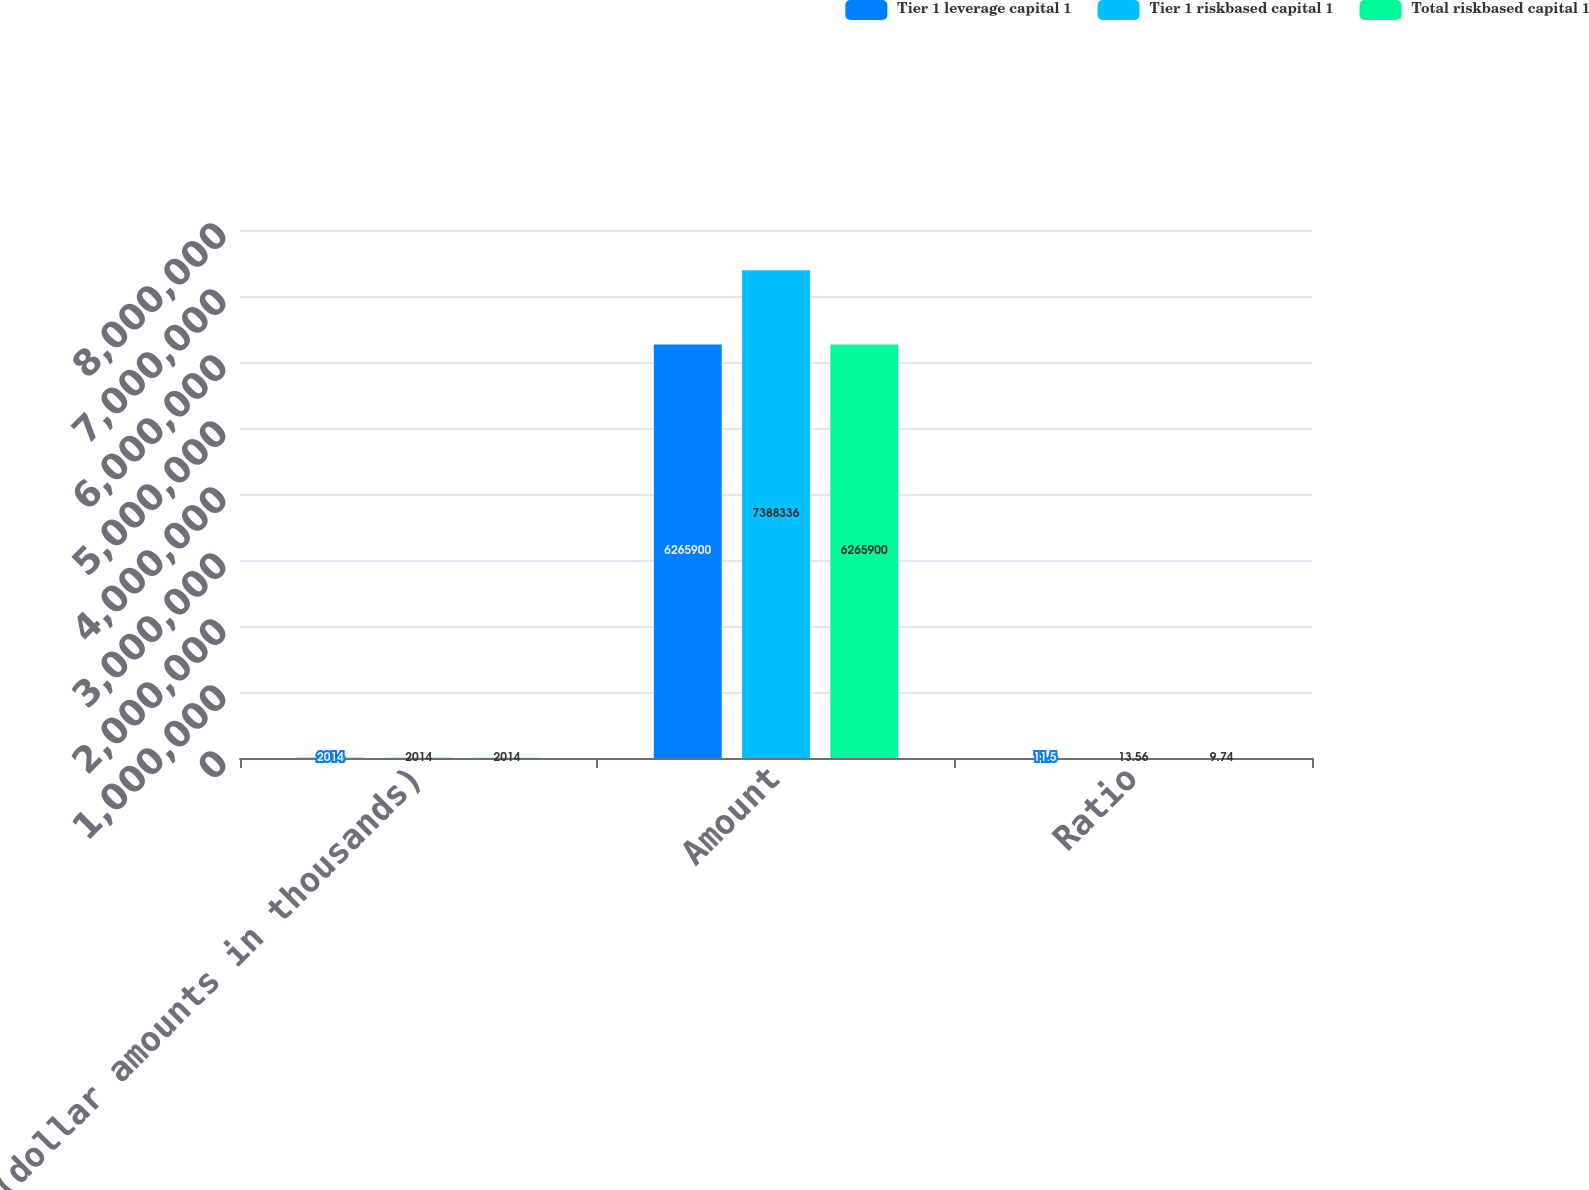<chart> <loc_0><loc_0><loc_500><loc_500><stacked_bar_chart><ecel><fcel>(dollar amounts in thousands)<fcel>Amount<fcel>Ratio<nl><fcel>Tier 1 leverage capital 1<fcel>2014<fcel>6.2659e+06<fcel>11.5<nl><fcel>Tier 1 riskbased capital 1<fcel>2014<fcel>7.38834e+06<fcel>13.56<nl><fcel>Total riskbased capital 1<fcel>2014<fcel>6.2659e+06<fcel>9.74<nl></chart> 